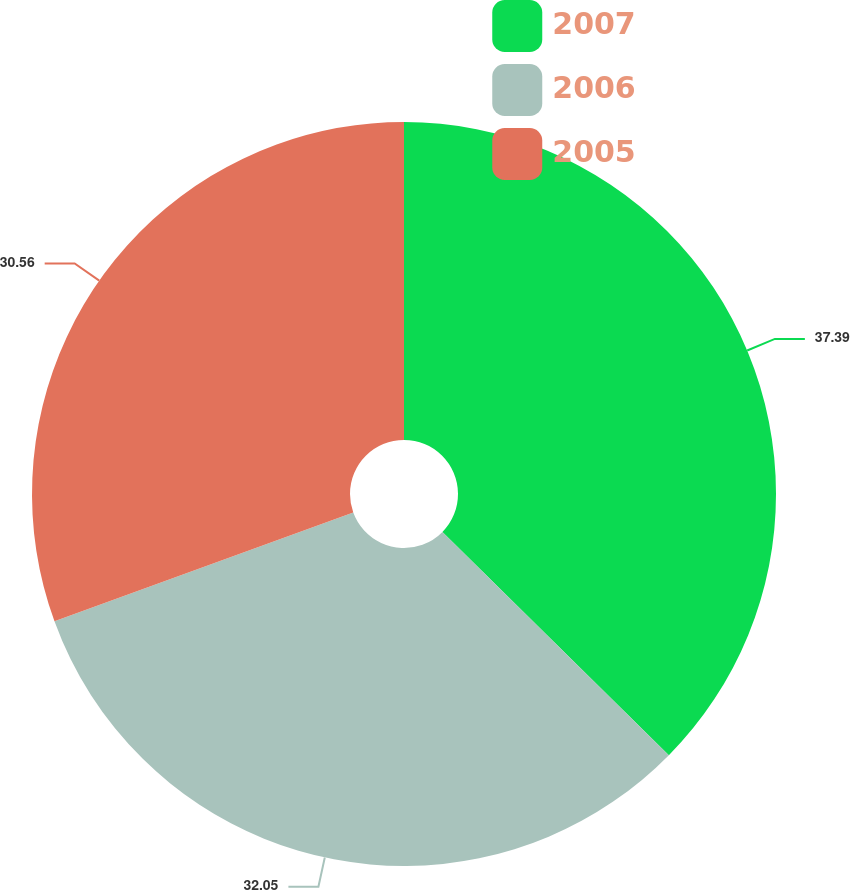Convert chart to OTSL. <chart><loc_0><loc_0><loc_500><loc_500><pie_chart><fcel>2007<fcel>2006<fcel>2005<nl><fcel>37.39%<fcel>32.05%<fcel>30.56%<nl></chart> 